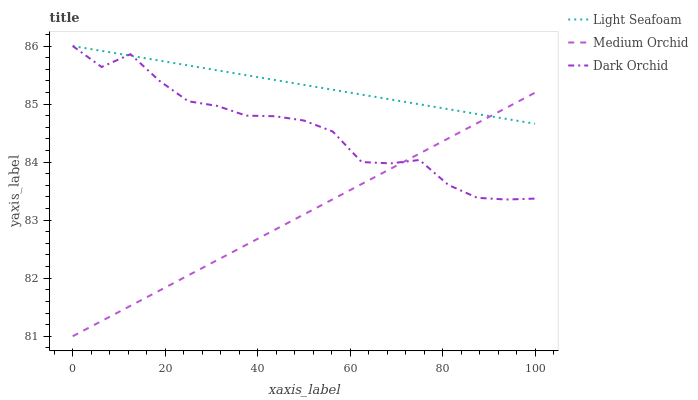Does Medium Orchid have the minimum area under the curve?
Answer yes or no. Yes. Does Light Seafoam have the maximum area under the curve?
Answer yes or no. Yes. Does Dark Orchid have the minimum area under the curve?
Answer yes or no. No. Does Dark Orchid have the maximum area under the curve?
Answer yes or no. No. Is Light Seafoam the smoothest?
Answer yes or no. Yes. Is Dark Orchid the roughest?
Answer yes or no. Yes. Is Dark Orchid the smoothest?
Answer yes or no. No. Is Light Seafoam the roughest?
Answer yes or no. No. Does Medium Orchid have the lowest value?
Answer yes or no. Yes. Does Dark Orchid have the lowest value?
Answer yes or no. No. Does Dark Orchid have the highest value?
Answer yes or no. Yes. Does Medium Orchid intersect Light Seafoam?
Answer yes or no. Yes. Is Medium Orchid less than Light Seafoam?
Answer yes or no. No. Is Medium Orchid greater than Light Seafoam?
Answer yes or no. No. 